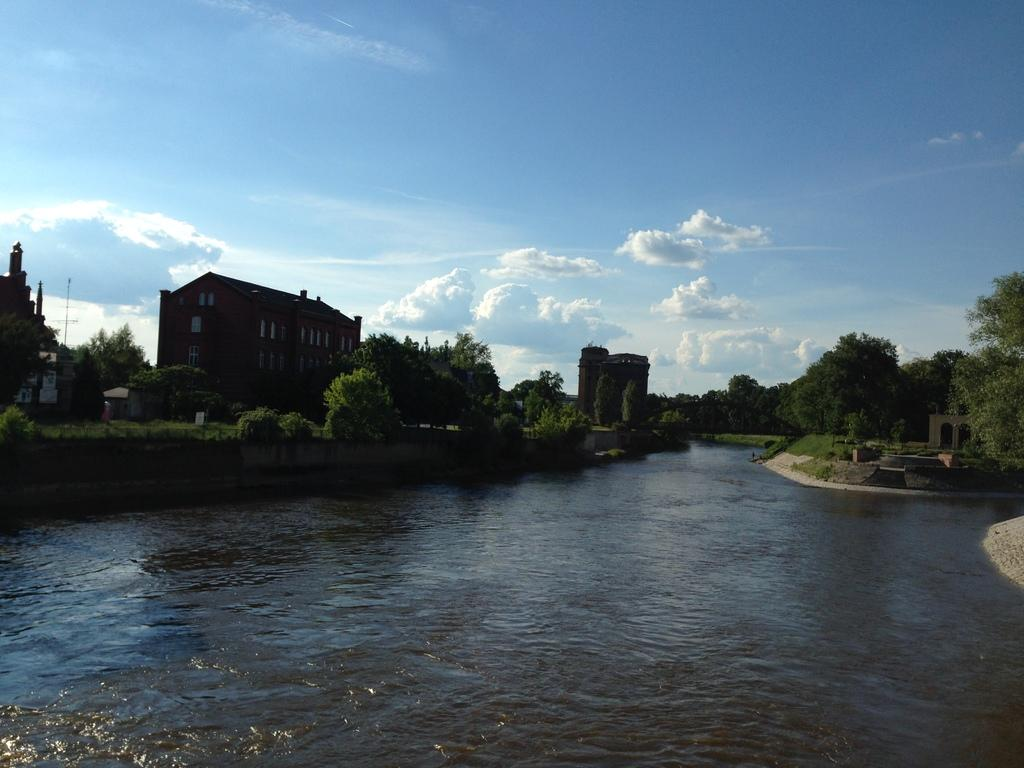What is the primary element visible in the image? There is water in the image. What type of vegetation can be seen in the image? There are green plants and trees in the image. What type of structure is present in the image? There is a building in the image. What color is the sky in the image? The sky is blue and visible at the top of the image. How many bricks are visible in the image? There is no reference to bricks in the image, so it is not possible to determine how many are visible. 